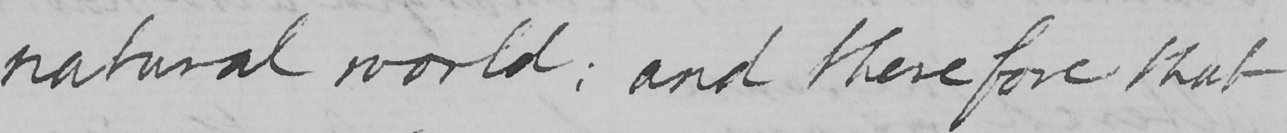Can you tell me what this handwritten text says? natural world :  and therefore that 